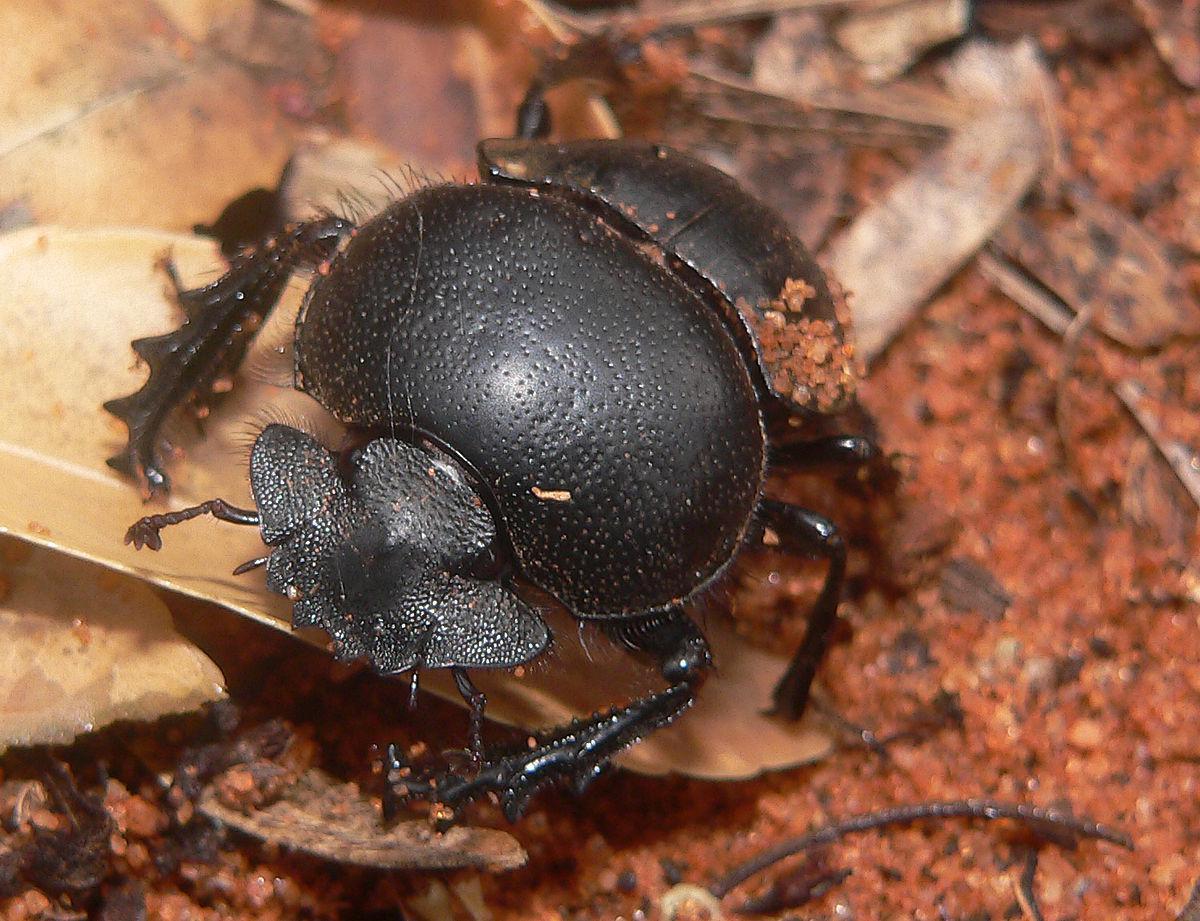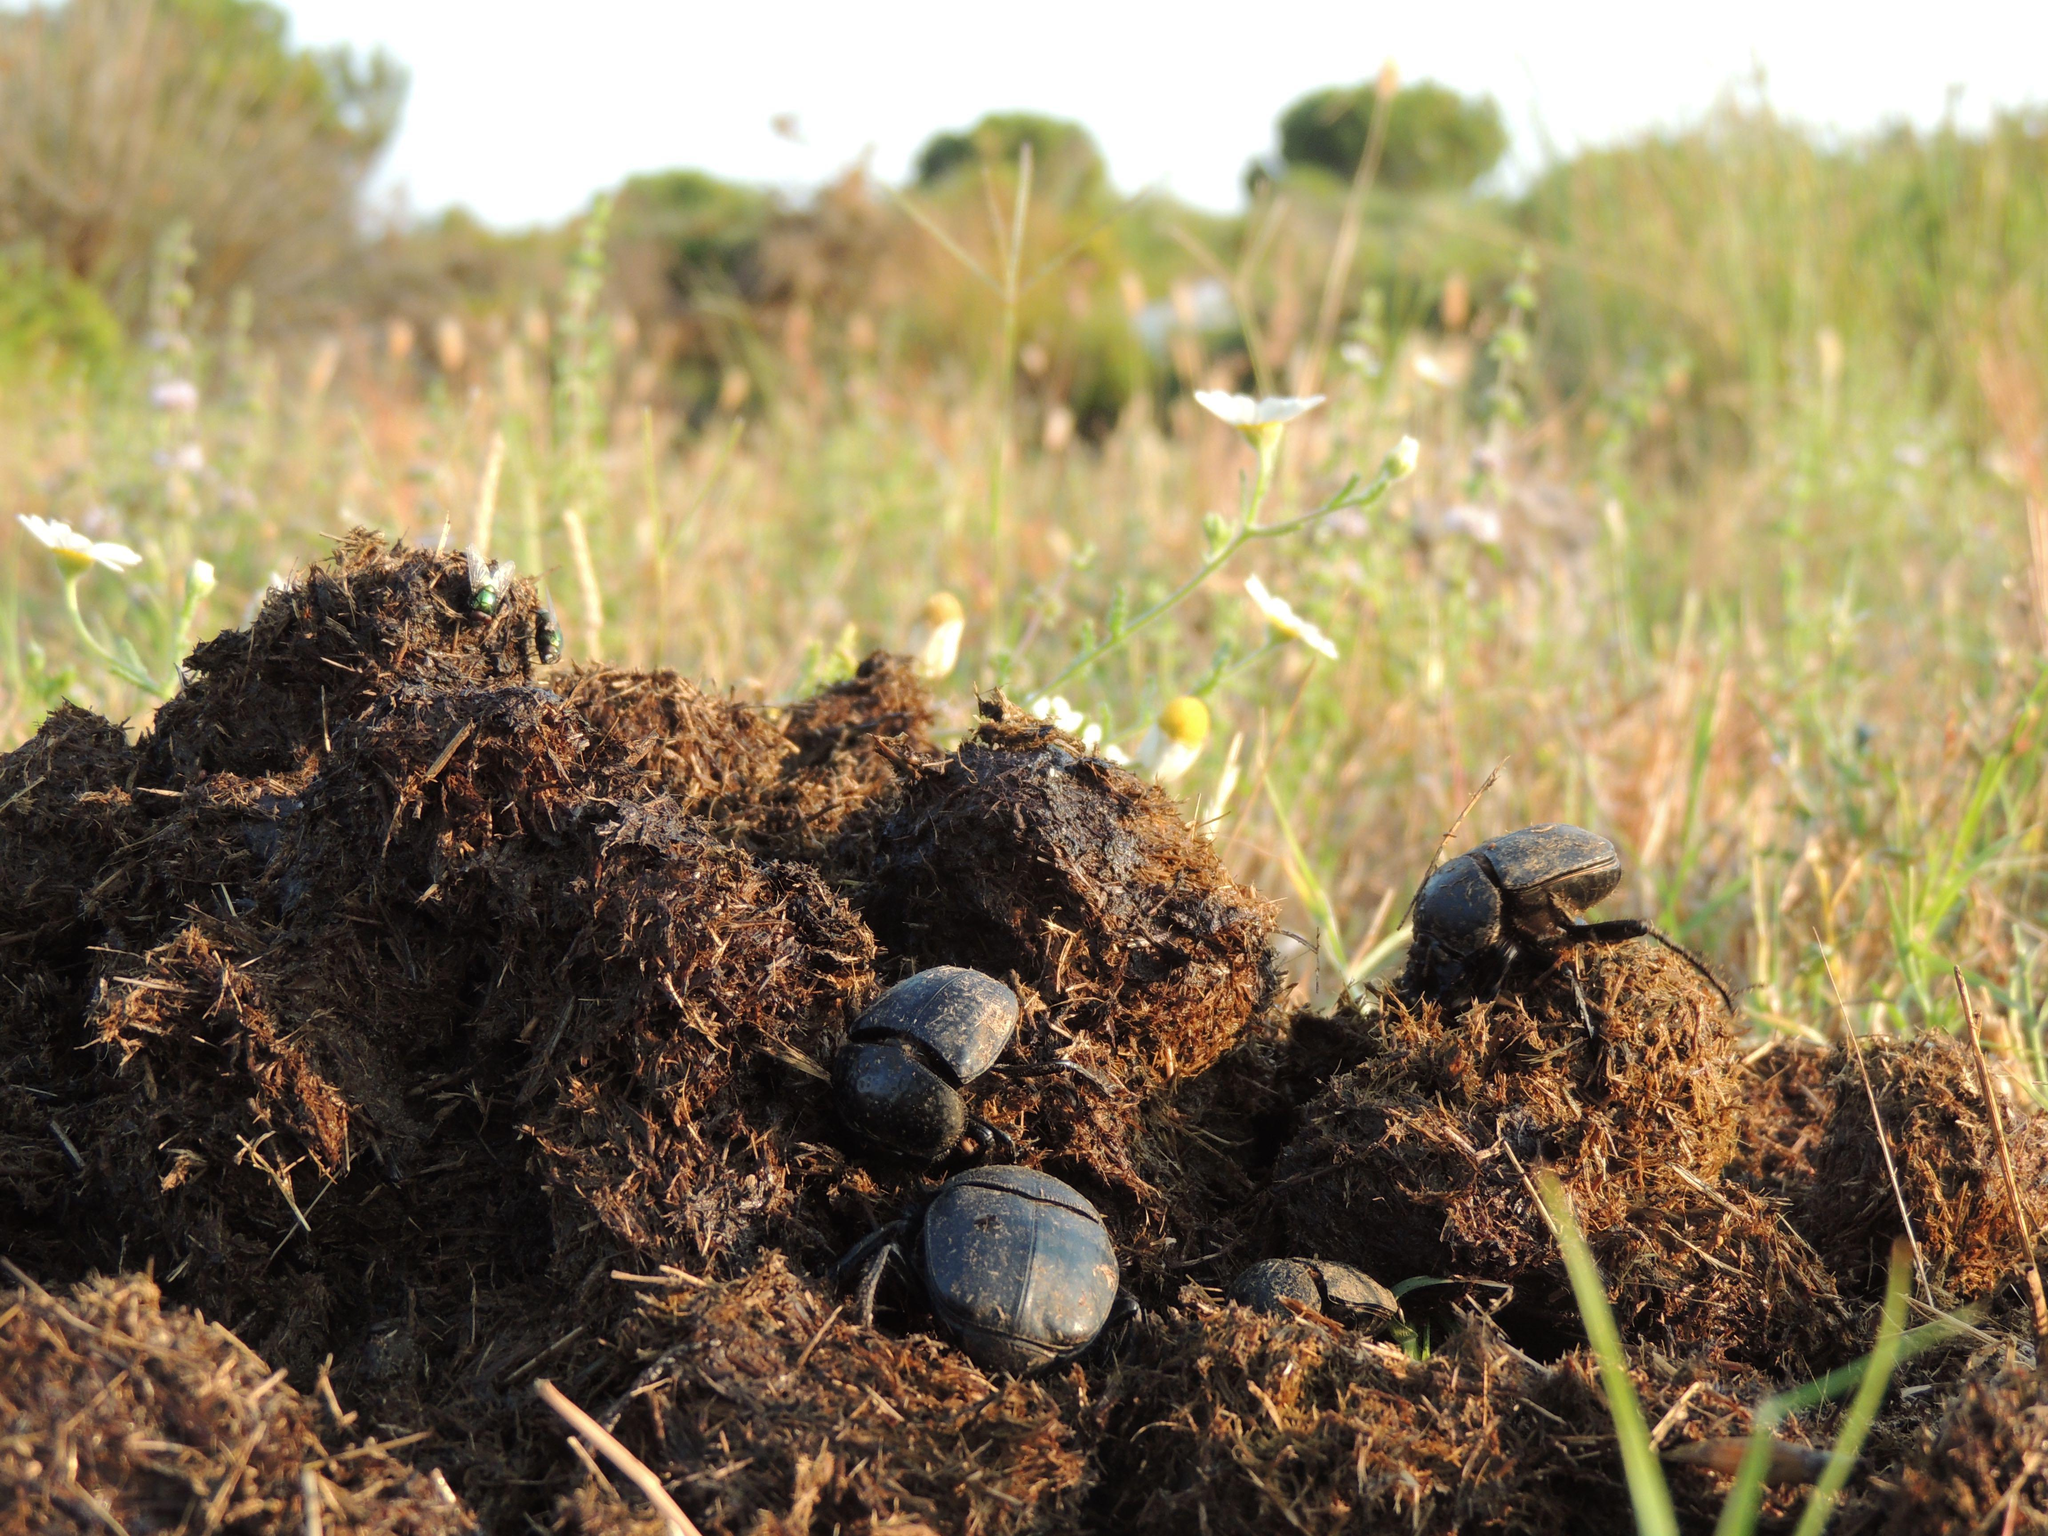The first image is the image on the left, the second image is the image on the right. For the images shown, is this caption "There is exactly one insect standing on top of the ball in one of the images." true? Answer yes or no. No. 